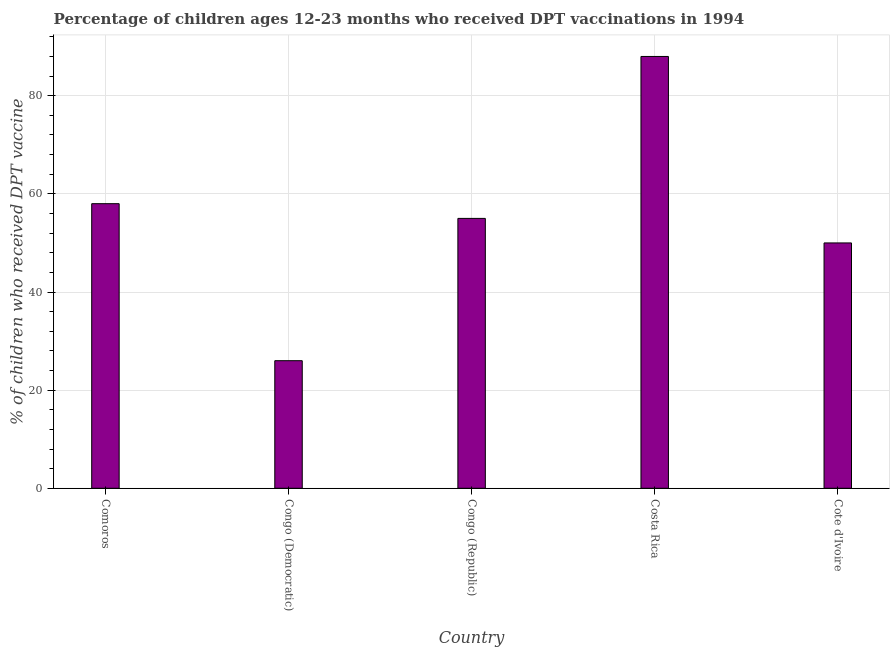Does the graph contain grids?
Offer a very short reply. Yes. What is the title of the graph?
Provide a short and direct response. Percentage of children ages 12-23 months who received DPT vaccinations in 1994. What is the label or title of the Y-axis?
Your response must be concise. % of children who received DPT vaccine. What is the percentage of children who received dpt vaccine in Congo (Democratic)?
Give a very brief answer. 26. Across all countries, what is the maximum percentage of children who received dpt vaccine?
Your answer should be very brief. 88. Across all countries, what is the minimum percentage of children who received dpt vaccine?
Ensure brevity in your answer.  26. In which country was the percentage of children who received dpt vaccine minimum?
Ensure brevity in your answer.  Congo (Democratic). What is the sum of the percentage of children who received dpt vaccine?
Offer a terse response. 277. What is the average percentage of children who received dpt vaccine per country?
Provide a succinct answer. 55.4. What is the median percentage of children who received dpt vaccine?
Your answer should be very brief. 55. In how many countries, is the percentage of children who received dpt vaccine greater than 72 %?
Ensure brevity in your answer.  1. What is the ratio of the percentage of children who received dpt vaccine in Congo (Democratic) to that in Costa Rica?
Your response must be concise. 0.29. Is the percentage of children who received dpt vaccine in Comoros less than that in Costa Rica?
Keep it short and to the point. Yes. What is the difference between the highest and the second highest percentage of children who received dpt vaccine?
Make the answer very short. 30. What is the difference between the highest and the lowest percentage of children who received dpt vaccine?
Keep it short and to the point. 62. Are all the bars in the graph horizontal?
Make the answer very short. No. Are the values on the major ticks of Y-axis written in scientific E-notation?
Your answer should be compact. No. What is the % of children who received DPT vaccine in Comoros?
Give a very brief answer. 58. What is the difference between the % of children who received DPT vaccine in Comoros and Congo (Democratic)?
Offer a very short reply. 32. What is the difference between the % of children who received DPT vaccine in Comoros and Congo (Republic)?
Offer a very short reply. 3. What is the difference between the % of children who received DPT vaccine in Congo (Democratic) and Congo (Republic)?
Your response must be concise. -29. What is the difference between the % of children who received DPT vaccine in Congo (Democratic) and Costa Rica?
Keep it short and to the point. -62. What is the difference between the % of children who received DPT vaccine in Congo (Democratic) and Cote d'Ivoire?
Give a very brief answer. -24. What is the difference between the % of children who received DPT vaccine in Congo (Republic) and Costa Rica?
Ensure brevity in your answer.  -33. What is the ratio of the % of children who received DPT vaccine in Comoros to that in Congo (Democratic)?
Provide a succinct answer. 2.23. What is the ratio of the % of children who received DPT vaccine in Comoros to that in Congo (Republic)?
Your answer should be compact. 1.05. What is the ratio of the % of children who received DPT vaccine in Comoros to that in Costa Rica?
Make the answer very short. 0.66. What is the ratio of the % of children who received DPT vaccine in Comoros to that in Cote d'Ivoire?
Provide a succinct answer. 1.16. What is the ratio of the % of children who received DPT vaccine in Congo (Democratic) to that in Congo (Republic)?
Your answer should be compact. 0.47. What is the ratio of the % of children who received DPT vaccine in Congo (Democratic) to that in Costa Rica?
Offer a terse response. 0.29. What is the ratio of the % of children who received DPT vaccine in Congo (Democratic) to that in Cote d'Ivoire?
Offer a very short reply. 0.52. What is the ratio of the % of children who received DPT vaccine in Congo (Republic) to that in Costa Rica?
Keep it short and to the point. 0.62. What is the ratio of the % of children who received DPT vaccine in Congo (Republic) to that in Cote d'Ivoire?
Provide a succinct answer. 1.1. What is the ratio of the % of children who received DPT vaccine in Costa Rica to that in Cote d'Ivoire?
Your answer should be compact. 1.76. 